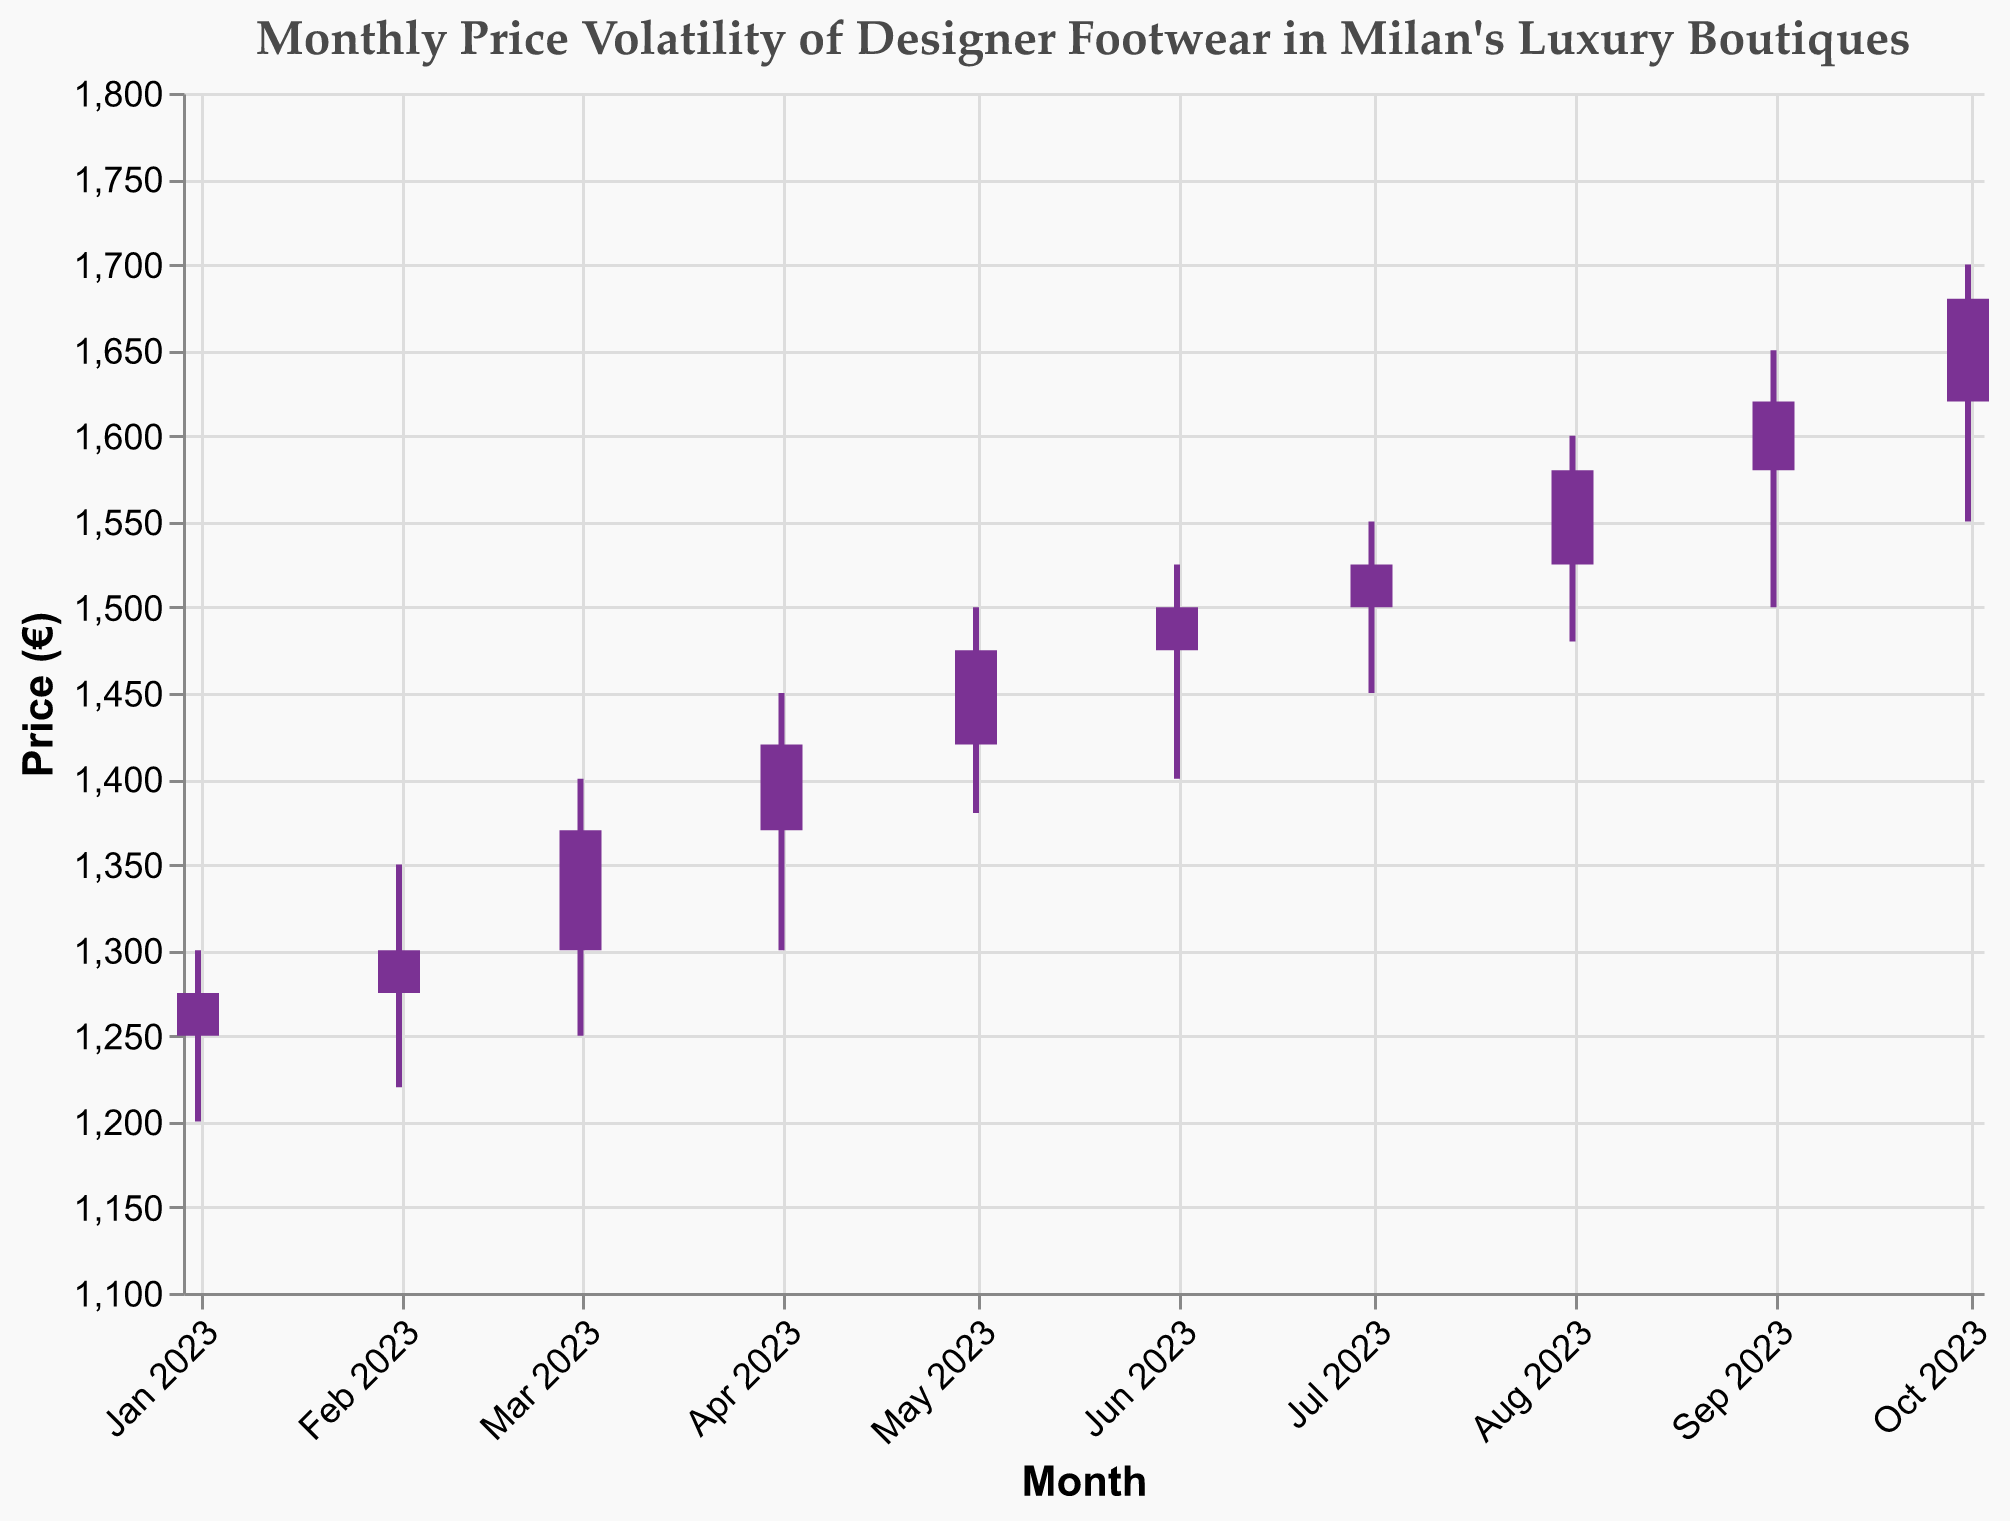What is the historical period covered by the plot? The x-axis shows the date range spanning from January 2023 to October 2023.
Answer: January 2023 to October 2023 What is the title of the figure? The title is positioned at the top of the plot and reads "Monthly Price Volatility of Designer Footwear in Milan's Luxury Boutiques".
Answer: Monthly Price Volatility of Designer Footwear in Milan's Luxury Boutiques Which month shows the highest price increase? In August 2023, the candlestick is colored indicating an increase from the opening to the closing price, and the highest high value is in August at 1600€.
Answer: August 2023 In which month did the closing price stay closest to the opening price? In June 2023, the candlestick shows very little difference between the opening price (1475€) and the closing price (1500€).
Answer: June 2023 What is the lowest recorded price and in which month? The lowest recorded price is represented by the "Low" line in January 2023, at 1200€.
Answer: January 2023 Which month had the highest closing price? The highest closing price is given by the top of the candlestick in October 2023, at 1680€.
Answer: October 2023 During which month was the price volatility the highest? Volatility can be assessed by the difference between the high and low prices. March 2023 shows a significant range between 1400€ (high) and 1250€ (low).
Answer: March 2023 How does the price trend from January 2023 to October 2023? Observing the closing prices each month from January (1275€) to October (1680€), there is a clear overall upward trend.
Answer: Upward trend What was the increase in the closing price from January to October 2023? Subtract the closing price in January (1275€) from the closing price in October (1680€): 1680€ - 1275€ = 405€.
Answer: 405€ Which month experienced a decrease in the closing price compared to the previous month? None of the months' candlesticks are colored uniquely to indicate a drop in the price, meaning every month has seen an increase or remains steady from the previous month.
Answer: None 